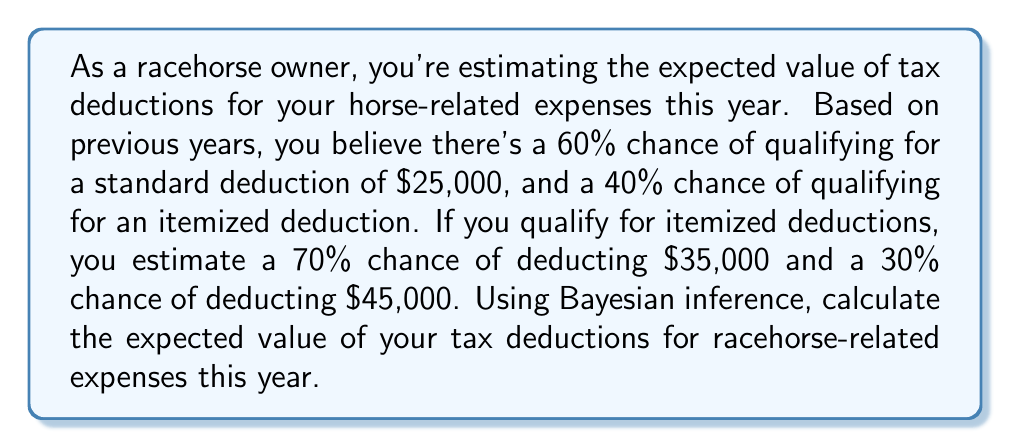What is the answer to this math problem? To solve this problem, we'll use the law of total expectation and Bayesian inference. Let's break it down step by step:

1) Define events:
   A: Qualify for standard deduction
   B: Qualify for itemized deduction
   C: Deduct $35,000 (given itemized)
   D: Deduct $45,000 (given itemized)

2) Given probabilities:
   $P(A) = 0.60$
   $P(B) = 1 - P(A) = 0.40$
   $P(C|B) = 0.70$
   $P(D|B) = 0.30$

3) Calculate expected value using the law of total expectation:

   $E[X] = E[X|A] \cdot P(A) + E[X|B] \cdot P(B)$

   Where $X$ is the deduction amount.

4) For standard deduction (A):
   $E[X|A] = $25,000$

5) For itemized deduction (B):
   $E[X|B] = $35,000 \cdot P(C|B) + $45,000 \cdot P(D|B)$
   $E[X|B] = 35000 \cdot 0.70 + 45000 \cdot 0.30$
   $E[X|B] = 24500 + 13500 = $38,000$

6) Now, let's plug these values into our total expectation formula:

   $E[X] = 25000 \cdot 0.60 + 38000 \cdot 0.40$
   $E[X] = 15000 + 15200 = $30,200$

Therefore, the expected value of tax deductions for racehorse-related expenses this year is $30,200.
Answer: $30,200 